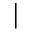<formula> <loc_0><loc_0><loc_500><loc_500>|</formula> 